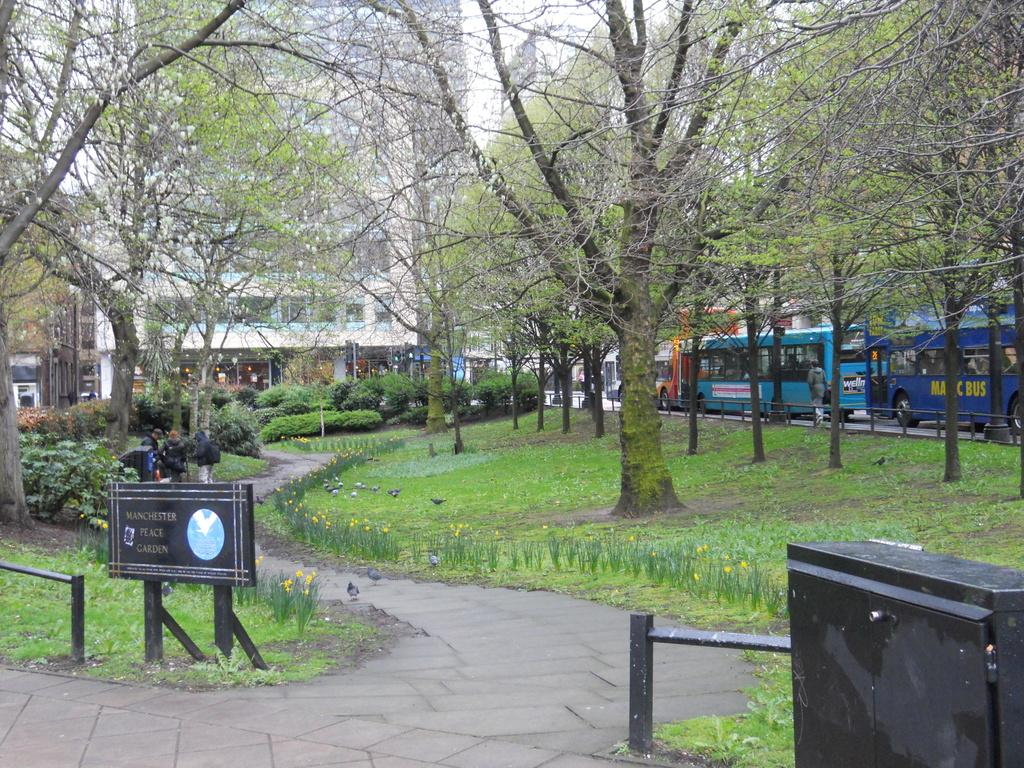What type of path is visible in the image? There is a walking lane in the image. What can be seen alongside the walking lane? There are trees along the walking lane. What mode of transportation is present on the right side of the image? There are buses on the right side of the image. What structure can be seen in the background of the image? There is a building in the background of the image. What type of protest is taking place in the image? There is no protest present in the image; it features a walking lane, trees, buses, and a building. What part of the day is depicted in the image? The time of day is not specified in the image, as there are no indicators such as shadows or lighting to suggest a specific time. 